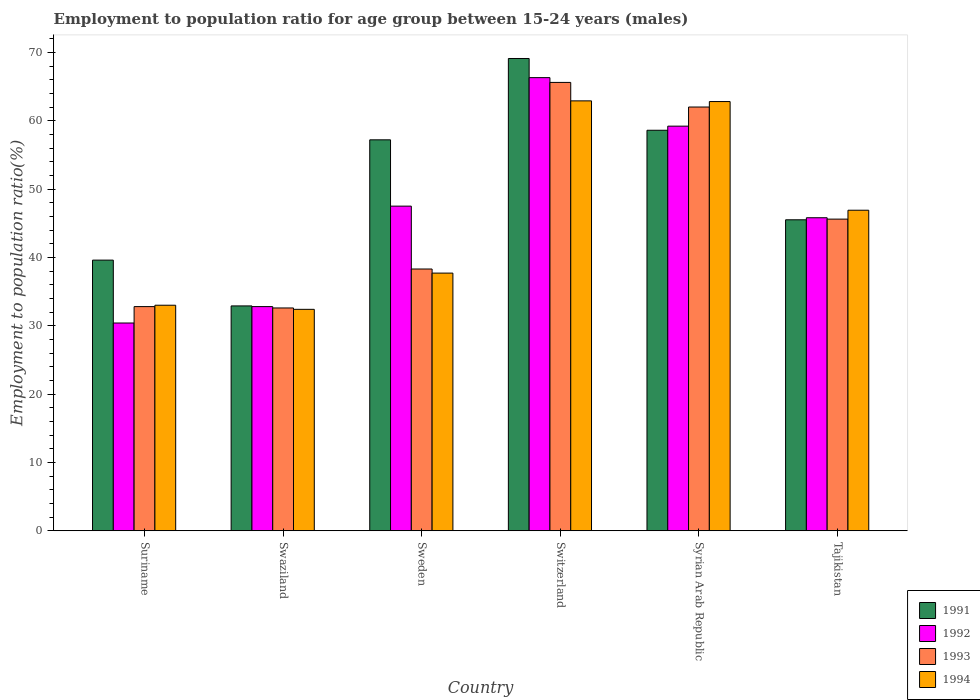How many different coloured bars are there?
Your answer should be very brief. 4. Are the number of bars per tick equal to the number of legend labels?
Give a very brief answer. Yes. How many bars are there on the 4th tick from the left?
Your answer should be compact. 4. What is the label of the 4th group of bars from the left?
Provide a short and direct response. Switzerland. What is the employment to population ratio in 1992 in Syrian Arab Republic?
Your response must be concise. 59.2. Across all countries, what is the maximum employment to population ratio in 1993?
Provide a succinct answer. 65.6. Across all countries, what is the minimum employment to population ratio in 1993?
Provide a short and direct response. 32.6. In which country was the employment to population ratio in 1992 maximum?
Provide a short and direct response. Switzerland. In which country was the employment to population ratio in 1991 minimum?
Offer a terse response. Swaziland. What is the total employment to population ratio in 1991 in the graph?
Provide a short and direct response. 302.9. What is the difference between the employment to population ratio in 1994 in Swaziland and that in Tajikistan?
Keep it short and to the point. -14.5. What is the difference between the employment to population ratio in 1991 in Tajikistan and the employment to population ratio in 1994 in Swaziland?
Your answer should be very brief. 13.1. What is the average employment to population ratio in 1992 per country?
Provide a succinct answer. 47. What is the difference between the employment to population ratio of/in 1993 and employment to population ratio of/in 1994 in Sweden?
Ensure brevity in your answer.  0.6. In how many countries, is the employment to population ratio in 1993 greater than 56 %?
Your answer should be very brief. 2. What is the ratio of the employment to population ratio in 1992 in Suriname to that in Sweden?
Your answer should be compact. 0.64. Is the employment to population ratio in 1994 in Sweden less than that in Tajikistan?
Your answer should be very brief. Yes. Is the difference between the employment to population ratio in 1993 in Suriname and Sweden greater than the difference between the employment to population ratio in 1994 in Suriname and Sweden?
Offer a terse response. No. What is the difference between the highest and the second highest employment to population ratio in 1993?
Provide a short and direct response. 20. What is the difference between the highest and the lowest employment to population ratio in 1992?
Your answer should be very brief. 35.9. Is it the case that in every country, the sum of the employment to population ratio in 1992 and employment to population ratio in 1991 is greater than the sum of employment to population ratio in 1994 and employment to population ratio in 1993?
Your answer should be compact. No. What does the 4th bar from the left in Syrian Arab Republic represents?
Offer a terse response. 1994. What does the 2nd bar from the right in Swaziland represents?
Your response must be concise. 1993. Are the values on the major ticks of Y-axis written in scientific E-notation?
Ensure brevity in your answer.  No. Does the graph contain grids?
Provide a succinct answer. No. What is the title of the graph?
Ensure brevity in your answer.  Employment to population ratio for age group between 15-24 years (males). What is the label or title of the Y-axis?
Offer a terse response. Employment to population ratio(%). What is the Employment to population ratio(%) in 1991 in Suriname?
Keep it short and to the point. 39.6. What is the Employment to population ratio(%) in 1992 in Suriname?
Your response must be concise. 30.4. What is the Employment to population ratio(%) of 1993 in Suriname?
Offer a very short reply. 32.8. What is the Employment to population ratio(%) in 1991 in Swaziland?
Ensure brevity in your answer.  32.9. What is the Employment to population ratio(%) in 1992 in Swaziland?
Give a very brief answer. 32.8. What is the Employment to population ratio(%) of 1993 in Swaziland?
Ensure brevity in your answer.  32.6. What is the Employment to population ratio(%) in 1994 in Swaziland?
Give a very brief answer. 32.4. What is the Employment to population ratio(%) of 1991 in Sweden?
Your answer should be compact. 57.2. What is the Employment to population ratio(%) of 1992 in Sweden?
Provide a short and direct response. 47.5. What is the Employment to population ratio(%) of 1993 in Sweden?
Offer a terse response. 38.3. What is the Employment to population ratio(%) in 1994 in Sweden?
Keep it short and to the point. 37.7. What is the Employment to population ratio(%) of 1991 in Switzerland?
Make the answer very short. 69.1. What is the Employment to population ratio(%) in 1992 in Switzerland?
Ensure brevity in your answer.  66.3. What is the Employment to population ratio(%) of 1993 in Switzerland?
Your response must be concise. 65.6. What is the Employment to population ratio(%) of 1994 in Switzerland?
Your answer should be compact. 62.9. What is the Employment to population ratio(%) of 1991 in Syrian Arab Republic?
Make the answer very short. 58.6. What is the Employment to population ratio(%) in 1992 in Syrian Arab Republic?
Offer a terse response. 59.2. What is the Employment to population ratio(%) of 1993 in Syrian Arab Republic?
Ensure brevity in your answer.  62. What is the Employment to population ratio(%) in 1994 in Syrian Arab Republic?
Your answer should be very brief. 62.8. What is the Employment to population ratio(%) in 1991 in Tajikistan?
Provide a short and direct response. 45.5. What is the Employment to population ratio(%) of 1992 in Tajikistan?
Your answer should be compact. 45.8. What is the Employment to population ratio(%) in 1993 in Tajikistan?
Offer a terse response. 45.6. What is the Employment to population ratio(%) in 1994 in Tajikistan?
Offer a terse response. 46.9. Across all countries, what is the maximum Employment to population ratio(%) of 1991?
Give a very brief answer. 69.1. Across all countries, what is the maximum Employment to population ratio(%) in 1992?
Keep it short and to the point. 66.3. Across all countries, what is the maximum Employment to population ratio(%) in 1993?
Your answer should be compact. 65.6. Across all countries, what is the maximum Employment to population ratio(%) of 1994?
Ensure brevity in your answer.  62.9. Across all countries, what is the minimum Employment to population ratio(%) of 1991?
Give a very brief answer. 32.9. Across all countries, what is the minimum Employment to population ratio(%) of 1992?
Keep it short and to the point. 30.4. Across all countries, what is the minimum Employment to population ratio(%) in 1993?
Offer a very short reply. 32.6. Across all countries, what is the minimum Employment to population ratio(%) of 1994?
Your answer should be compact. 32.4. What is the total Employment to population ratio(%) of 1991 in the graph?
Provide a succinct answer. 302.9. What is the total Employment to population ratio(%) of 1992 in the graph?
Provide a succinct answer. 282. What is the total Employment to population ratio(%) in 1993 in the graph?
Offer a terse response. 276.9. What is the total Employment to population ratio(%) of 1994 in the graph?
Provide a short and direct response. 275.7. What is the difference between the Employment to population ratio(%) of 1992 in Suriname and that in Swaziland?
Make the answer very short. -2.4. What is the difference between the Employment to population ratio(%) of 1994 in Suriname and that in Swaziland?
Ensure brevity in your answer.  0.6. What is the difference between the Employment to population ratio(%) of 1991 in Suriname and that in Sweden?
Your response must be concise. -17.6. What is the difference between the Employment to population ratio(%) in 1992 in Suriname and that in Sweden?
Your answer should be very brief. -17.1. What is the difference between the Employment to population ratio(%) in 1993 in Suriname and that in Sweden?
Ensure brevity in your answer.  -5.5. What is the difference between the Employment to population ratio(%) in 1994 in Suriname and that in Sweden?
Ensure brevity in your answer.  -4.7. What is the difference between the Employment to population ratio(%) of 1991 in Suriname and that in Switzerland?
Give a very brief answer. -29.5. What is the difference between the Employment to population ratio(%) of 1992 in Suriname and that in Switzerland?
Your answer should be very brief. -35.9. What is the difference between the Employment to population ratio(%) of 1993 in Suriname and that in Switzerland?
Provide a succinct answer. -32.8. What is the difference between the Employment to population ratio(%) of 1994 in Suriname and that in Switzerland?
Ensure brevity in your answer.  -29.9. What is the difference between the Employment to population ratio(%) of 1991 in Suriname and that in Syrian Arab Republic?
Offer a very short reply. -19. What is the difference between the Employment to population ratio(%) in 1992 in Suriname and that in Syrian Arab Republic?
Keep it short and to the point. -28.8. What is the difference between the Employment to population ratio(%) of 1993 in Suriname and that in Syrian Arab Republic?
Keep it short and to the point. -29.2. What is the difference between the Employment to population ratio(%) of 1994 in Suriname and that in Syrian Arab Republic?
Offer a very short reply. -29.8. What is the difference between the Employment to population ratio(%) of 1992 in Suriname and that in Tajikistan?
Your answer should be very brief. -15.4. What is the difference between the Employment to population ratio(%) of 1993 in Suriname and that in Tajikistan?
Give a very brief answer. -12.8. What is the difference between the Employment to population ratio(%) in 1994 in Suriname and that in Tajikistan?
Keep it short and to the point. -13.9. What is the difference between the Employment to population ratio(%) in 1991 in Swaziland and that in Sweden?
Your answer should be very brief. -24.3. What is the difference between the Employment to population ratio(%) in 1992 in Swaziland and that in Sweden?
Offer a very short reply. -14.7. What is the difference between the Employment to population ratio(%) in 1993 in Swaziland and that in Sweden?
Your response must be concise. -5.7. What is the difference between the Employment to population ratio(%) of 1994 in Swaziland and that in Sweden?
Your answer should be very brief. -5.3. What is the difference between the Employment to population ratio(%) of 1991 in Swaziland and that in Switzerland?
Give a very brief answer. -36.2. What is the difference between the Employment to population ratio(%) of 1992 in Swaziland and that in Switzerland?
Your response must be concise. -33.5. What is the difference between the Employment to population ratio(%) in 1993 in Swaziland and that in Switzerland?
Give a very brief answer. -33. What is the difference between the Employment to population ratio(%) of 1994 in Swaziland and that in Switzerland?
Provide a short and direct response. -30.5. What is the difference between the Employment to population ratio(%) of 1991 in Swaziland and that in Syrian Arab Republic?
Your answer should be compact. -25.7. What is the difference between the Employment to population ratio(%) in 1992 in Swaziland and that in Syrian Arab Republic?
Your answer should be compact. -26.4. What is the difference between the Employment to population ratio(%) in 1993 in Swaziland and that in Syrian Arab Republic?
Provide a succinct answer. -29.4. What is the difference between the Employment to population ratio(%) in 1994 in Swaziland and that in Syrian Arab Republic?
Your answer should be compact. -30.4. What is the difference between the Employment to population ratio(%) of 1991 in Swaziland and that in Tajikistan?
Your response must be concise. -12.6. What is the difference between the Employment to population ratio(%) of 1992 in Swaziland and that in Tajikistan?
Make the answer very short. -13. What is the difference between the Employment to population ratio(%) of 1993 in Swaziland and that in Tajikistan?
Make the answer very short. -13. What is the difference between the Employment to population ratio(%) of 1994 in Swaziland and that in Tajikistan?
Offer a terse response. -14.5. What is the difference between the Employment to population ratio(%) of 1992 in Sweden and that in Switzerland?
Make the answer very short. -18.8. What is the difference between the Employment to population ratio(%) of 1993 in Sweden and that in Switzerland?
Give a very brief answer. -27.3. What is the difference between the Employment to population ratio(%) in 1994 in Sweden and that in Switzerland?
Keep it short and to the point. -25.2. What is the difference between the Employment to population ratio(%) in 1992 in Sweden and that in Syrian Arab Republic?
Give a very brief answer. -11.7. What is the difference between the Employment to population ratio(%) of 1993 in Sweden and that in Syrian Arab Republic?
Give a very brief answer. -23.7. What is the difference between the Employment to population ratio(%) in 1994 in Sweden and that in Syrian Arab Republic?
Offer a terse response. -25.1. What is the difference between the Employment to population ratio(%) of 1991 in Sweden and that in Tajikistan?
Offer a very short reply. 11.7. What is the difference between the Employment to population ratio(%) in 1993 in Sweden and that in Tajikistan?
Your answer should be very brief. -7.3. What is the difference between the Employment to population ratio(%) of 1994 in Sweden and that in Tajikistan?
Your answer should be compact. -9.2. What is the difference between the Employment to population ratio(%) of 1992 in Switzerland and that in Syrian Arab Republic?
Give a very brief answer. 7.1. What is the difference between the Employment to population ratio(%) in 1993 in Switzerland and that in Syrian Arab Republic?
Your answer should be compact. 3.6. What is the difference between the Employment to population ratio(%) of 1991 in Switzerland and that in Tajikistan?
Your answer should be compact. 23.6. What is the difference between the Employment to population ratio(%) in 1993 in Switzerland and that in Tajikistan?
Offer a very short reply. 20. What is the difference between the Employment to population ratio(%) of 1991 in Syrian Arab Republic and that in Tajikistan?
Offer a terse response. 13.1. What is the difference between the Employment to population ratio(%) in 1992 in Syrian Arab Republic and that in Tajikistan?
Your answer should be very brief. 13.4. What is the difference between the Employment to population ratio(%) of 1994 in Syrian Arab Republic and that in Tajikistan?
Give a very brief answer. 15.9. What is the difference between the Employment to population ratio(%) of 1991 in Suriname and the Employment to population ratio(%) of 1993 in Swaziland?
Offer a terse response. 7. What is the difference between the Employment to population ratio(%) of 1991 in Suriname and the Employment to population ratio(%) of 1992 in Sweden?
Offer a very short reply. -7.9. What is the difference between the Employment to population ratio(%) in 1992 in Suriname and the Employment to population ratio(%) in 1994 in Sweden?
Make the answer very short. -7.3. What is the difference between the Employment to population ratio(%) in 1991 in Suriname and the Employment to population ratio(%) in 1992 in Switzerland?
Offer a very short reply. -26.7. What is the difference between the Employment to population ratio(%) of 1991 in Suriname and the Employment to population ratio(%) of 1993 in Switzerland?
Your response must be concise. -26. What is the difference between the Employment to population ratio(%) in 1991 in Suriname and the Employment to population ratio(%) in 1994 in Switzerland?
Offer a very short reply. -23.3. What is the difference between the Employment to population ratio(%) in 1992 in Suriname and the Employment to population ratio(%) in 1993 in Switzerland?
Provide a succinct answer. -35.2. What is the difference between the Employment to population ratio(%) in 1992 in Suriname and the Employment to population ratio(%) in 1994 in Switzerland?
Ensure brevity in your answer.  -32.5. What is the difference between the Employment to population ratio(%) of 1993 in Suriname and the Employment to population ratio(%) of 1994 in Switzerland?
Ensure brevity in your answer.  -30.1. What is the difference between the Employment to population ratio(%) of 1991 in Suriname and the Employment to population ratio(%) of 1992 in Syrian Arab Republic?
Your response must be concise. -19.6. What is the difference between the Employment to population ratio(%) in 1991 in Suriname and the Employment to population ratio(%) in 1993 in Syrian Arab Republic?
Your response must be concise. -22.4. What is the difference between the Employment to population ratio(%) of 1991 in Suriname and the Employment to population ratio(%) of 1994 in Syrian Arab Republic?
Provide a succinct answer. -23.2. What is the difference between the Employment to population ratio(%) in 1992 in Suriname and the Employment to population ratio(%) in 1993 in Syrian Arab Republic?
Your answer should be very brief. -31.6. What is the difference between the Employment to population ratio(%) of 1992 in Suriname and the Employment to population ratio(%) of 1994 in Syrian Arab Republic?
Ensure brevity in your answer.  -32.4. What is the difference between the Employment to population ratio(%) in 1991 in Suriname and the Employment to population ratio(%) in 1992 in Tajikistan?
Your answer should be compact. -6.2. What is the difference between the Employment to population ratio(%) of 1991 in Suriname and the Employment to population ratio(%) of 1993 in Tajikistan?
Your response must be concise. -6. What is the difference between the Employment to population ratio(%) in 1992 in Suriname and the Employment to population ratio(%) in 1993 in Tajikistan?
Provide a short and direct response. -15.2. What is the difference between the Employment to population ratio(%) of 1992 in Suriname and the Employment to population ratio(%) of 1994 in Tajikistan?
Your answer should be very brief. -16.5. What is the difference between the Employment to population ratio(%) in 1993 in Suriname and the Employment to population ratio(%) in 1994 in Tajikistan?
Ensure brevity in your answer.  -14.1. What is the difference between the Employment to population ratio(%) of 1991 in Swaziland and the Employment to population ratio(%) of 1992 in Sweden?
Keep it short and to the point. -14.6. What is the difference between the Employment to population ratio(%) in 1991 in Swaziland and the Employment to population ratio(%) in 1994 in Sweden?
Ensure brevity in your answer.  -4.8. What is the difference between the Employment to population ratio(%) of 1992 in Swaziland and the Employment to population ratio(%) of 1993 in Sweden?
Keep it short and to the point. -5.5. What is the difference between the Employment to population ratio(%) of 1992 in Swaziland and the Employment to population ratio(%) of 1994 in Sweden?
Your answer should be very brief. -4.9. What is the difference between the Employment to population ratio(%) in 1993 in Swaziland and the Employment to population ratio(%) in 1994 in Sweden?
Make the answer very short. -5.1. What is the difference between the Employment to population ratio(%) in 1991 in Swaziland and the Employment to population ratio(%) in 1992 in Switzerland?
Keep it short and to the point. -33.4. What is the difference between the Employment to population ratio(%) in 1991 in Swaziland and the Employment to population ratio(%) in 1993 in Switzerland?
Keep it short and to the point. -32.7. What is the difference between the Employment to population ratio(%) in 1991 in Swaziland and the Employment to population ratio(%) in 1994 in Switzerland?
Offer a terse response. -30. What is the difference between the Employment to population ratio(%) of 1992 in Swaziland and the Employment to population ratio(%) of 1993 in Switzerland?
Provide a short and direct response. -32.8. What is the difference between the Employment to population ratio(%) of 1992 in Swaziland and the Employment to population ratio(%) of 1994 in Switzerland?
Your answer should be very brief. -30.1. What is the difference between the Employment to population ratio(%) in 1993 in Swaziland and the Employment to population ratio(%) in 1994 in Switzerland?
Your answer should be compact. -30.3. What is the difference between the Employment to population ratio(%) of 1991 in Swaziland and the Employment to population ratio(%) of 1992 in Syrian Arab Republic?
Provide a short and direct response. -26.3. What is the difference between the Employment to population ratio(%) in 1991 in Swaziland and the Employment to population ratio(%) in 1993 in Syrian Arab Republic?
Provide a short and direct response. -29.1. What is the difference between the Employment to population ratio(%) in 1991 in Swaziland and the Employment to population ratio(%) in 1994 in Syrian Arab Republic?
Your answer should be compact. -29.9. What is the difference between the Employment to population ratio(%) in 1992 in Swaziland and the Employment to population ratio(%) in 1993 in Syrian Arab Republic?
Ensure brevity in your answer.  -29.2. What is the difference between the Employment to population ratio(%) of 1993 in Swaziland and the Employment to population ratio(%) of 1994 in Syrian Arab Republic?
Offer a terse response. -30.2. What is the difference between the Employment to population ratio(%) of 1991 in Swaziland and the Employment to population ratio(%) of 1992 in Tajikistan?
Provide a short and direct response. -12.9. What is the difference between the Employment to population ratio(%) in 1992 in Swaziland and the Employment to population ratio(%) in 1994 in Tajikistan?
Give a very brief answer. -14.1. What is the difference between the Employment to population ratio(%) of 1993 in Swaziland and the Employment to population ratio(%) of 1994 in Tajikistan?
Your response must be concise. -14.3. What is the difference between the Employment to population ratio(%) in 1991 in Sweden and the Employment to population ratio(%) in 1992 in Switzerland?
Keep it short and to the point. -9.1. What is the difference between the Employment to population ratio(%) of 1991 in Sweden and the Employment to population ratio(%) of 1994 in Switzerland?
Ensure brevity in your answer.  -5.7. What is the difference between the Employment to population ratio(%) in 1992 in Sweden and the Employment to population ratio(%) in 1993 in Switzerland?
Your answer should be compact. -18.1. What is the difference between the Employment to population ratio(%) of 1992 in Sweden and the Employment to population ratio(%) of 1994 in Switzerland?
Keep it short and to the point. -15.4. What is the difference between the Employment to population ratio(%) in 1993 in Sweden and the Employment to population ratio(%) in 1994 in Switzerland?
Ensure brevity in your answer.  -24.6. What is the difference between the Employment to population ratio(%) of 1991 in Sweden and the Employment to population ratio(%) of 1993 in Syrian Arab Republic?
Your answer should be very brief. -4.8. What is the difference between the Employment to population ratio(%) in 1992 in Sweden and the Employment to population ratio(%) in 1994 in Syrian Arab Republic?
Provide a short and direct response. -15.3. What is the difference between the Employment to population ratio(%) in 1993 in Sweden and the Employment to population ratio(%) in 1994 in Syrian Arab Republic?
Ensure brevity in your answer.  -24.5. What is the difference between the Employment to population ratio(%) of 1991 in Sweden and the Employment to population ratio(%) of 1992 in Tajikistan?
Provide a succinct answer. 11.4. What is the difference between the Employment to population ratio(%) of 1991 in Sweden and the Employment to population ratio(%) of 1994 in Tajikistan?
Your answer should be very brief. 10.3. What is the difference between the Employment to population ratio(%) in 1992 in Sweden and the Employment to population ratio(%) in 1993 in Tajikistan?
Ensure brevity in your answer.  1.9. What is the difference between the Employment to population ratio(%) in 1993 in Sweden and the Employment to population ratio(%) in 1994 in Tajikistan?
Make the answer very short. -8.6. What is the difference between the Employment to population ratio(%) of 1991 in Switzerland and the Employment to population ratio(%) of 1992 in Syrian Arab Republic?
Ensure brevity in your answer.  9.9. What is the difference between the Employment to population ratio(%) of 1991 in Switzerland and the Employment to population ratio(%) of 1993 in Syrian Arab Republic?
Keep it short and to the point. 7.1. What is the difference between the Employment to population ratio(%) in 1991 in Switzerland and the Employment to population ratio(%) in 1992 in Tajikistan?
Ensure brevity in your answer.  23.3. What is the difference between the Employment to population ratio(%) of 1991 in Switzerland and the Employment to population ratio(%) of 1993 in Tajikistan?
Keep it short and to the point. 23.5. What is the difference between the Employment to population ratio(%) in 1991 in Switzerland and the Employment to population ratio(%) in 1994 in Tajikistan?
Offer a very short reply. 22.2. What is the difference between the Employment to population ratio(%) of 1992 in Switzerland and the Employment to population ratio(%) of 1993 in Tajikistan?
Provide a short and direct response. 20.7. What is the difference between the Employment to population ratio(%) of 1992 in Switzerland and the Employment to population ratio(%) of 1994 in Tajikistan?
Ensure brevity in your answer.  19.4. What is the difference between the Employment to population ratio(%) in 1993 in Switzerland and the Employment to population ratio(%) in 1994 in Tajikistan?
Ensure brevity in your answer.  18.7. What is the difference between the Employment to population ratio(%) in 1991 in Syrian Arab Republic and the Employment to population ratio(%) in 1992 in Tajikistan?
Offer a terse response. 12.8. What is the difference between the Employment to population ratio(%) in 1991 in Syrian Arab Republic and the Employment to population ratio(%) in 1993 in Tajikistan?
Your response must be concise. 13. What is the difference between the Employment to population ratio(%) of 1991 in Syrian Arab Republic and the Employment to population ratio(%) of 1994 in Tajikistan?
Make the answer very short. 11.7. What is the difference between the Employment to population ratio(%) of 1992 in Syrian Arab Republic and the Employment to population ratio(%) of 1993 in Tajikistan?
Provide a short and direct response. 13.6. What is the difference between the Employment to population ratio(%) in 1992 in Syrian Arab Republic and the Employment to population ratio(%) in 1994 in Tajikistan?
Offer a very short reply. 12.3. What is the difference between the Employment to population ratio(%) of 1993 in Syrian Arab Republic and the Employment to population ratio(%) of 1994 in Tajikistan?
Your answer should be compact. 15.1. What is the average Employment to population ratio(%) of 1991 per country?
Your answer should be very brief. 50.48. What is the average Employment to population ratio(%) in 1992 per country?
Provide a short and direct response. 47. What is the average Employment to population ratio(%) of 1993 per country?
Offer a very short reply. 46.15. What is the average Employment to population ratio(%) in 1994 per country?
Provide a succinct answer. 45.95. What is the difference between the Employment to population ratio(%) in 1991 and Employment to population ratio(%) in 1992 in Suriname?
Your answer should be very brief. 9.2. What is the difference between the Employment to population ratio(%) of 1991 and Employment to population ratio(%) of 1993 in Suriname?
Offer a very short reply. 6.8. What is the difference between the Employment to population ratio(%) in 1993 and Employment to population ratio(%) in 1994 in Suriname?
Ensure brevity in your answer.  -0.2. What is the difference between the Employment to population ratio(%) in 1991 and Employment to population ratio(%) in 1992 in Swaziland?
Make the answer very short. 0.1. What is the difference between the Employment to population ratio(%) of 1991 and Employment to population ratio(%) of 1994 in Swaziland?
Provide a short and direct response. 0.5. What is the difference between the Employment to population ratio(%) in 1992 and Employment to population ratio(%) in 1994 in Swaziland?
Provide a succinct answer. 0.4. What is the difference between the Employment to population ratio(%) in 1991 and Employment to population ratio(%) in 1994 in Sweden?
Offer a very short reply. 19.5. What is the difference between the Employment to population ratio(%) of 1992 and Employment to population ratio(%) of 1994 in Sweden?
Your answer should be very brief. 9.8. What is the difference between the Employment to population ratio(%) in 1991 and Employment to population ratio(%) in 1992 in Switzerland?
Provide a short and direct response. 2.8. What is the difference between the Employment to population ratio(%) of 1991 and Employment to population ratio(%) of 1994 in Switzerland?
Your answer should be compact. 6.2. What is the difference between the Employment to population ratio(%) of 1992 and Employment to population ratio(%) of 1993 in Switzerland?
Give a very brief answer. 0.7. What is the difference between the Employment to population ratio(%) in 1991 and Employment to population ratio(%) in 1992 in Syrian Arab Republic?
Provide a short and direct response. -0.6. What is the difference between the Employment to population ratio(%) in 1991 and Employment to population ratio(%) in 1994 in Syrian Arab Republic?
Your answer should be compact. -4.2. What is the difference between the Employment to population ratio(%) of 1992 and Employment to population ratio(%) of 1993 in Syrian Arab Republic?
Provide a short and direct response. -2.8. What is the difference between the Employment to population ratio(%) of 1991 and Employment to population ratio(%) of 1993 in Tajikistan?
Make the answer very short. -0.1. What is the difference between the Employment to population ratio(%) of 1992 and Employment to population ratio(%) of 1993 in Tajikistan?
Provide a short and direct response. 0.2. What is the difference between the Employment to population ratio(%) of 1992 and Employment to population ratio(%) of 1994 in Tajikistan?
Your response must be concise. -1.1. What is the difference between the Employment to population ratio(%) in 1993 and Employment to population ratio(%) in 1994 in Tajikistan?
Provide a short and direct response. -1.3. What is the ratio of the Employment to population ratio(%) in 1991 in Suriname to that in Swaziland?
Ensure brevity in your answer.  1.2. What is the ratio of the Employment to population ratio(%) of 1992 in Suriname to that in Swaziland?
Provide a succinct answer. 0.93. What is the ratio of the Employment to population ratio(%) in 1993 in Suriname to that in Swaziland?
Your answer should be compact. 1.01. What is the ratio of the Employment to population ratio(%) of 1994 in Suriname to that in Swaziland?
Your answer should be compact. 1.02. What is the ratio of the Employment to population ratio(%) of 1991 in Suriname to that in Sweden?
Provide a succinct answer. 0.69. What is the ratio of the Employment to population ratio(%) in 1992 in Suriname to that in Sweden?
Your response must be concise. 0.64. What is the ratio of the Employment to population ratio(%) of 1993 in Suriname to that in Sweden?
Provide a succinct answer. 0.86. What is the ratio of the Employment to population ratio(%) in 1994 in Suriname to that in Sweden?
Provide a short and direct response. 0.88. What is the ratio of the Employment to population ratio(%) in 1991 in Suriname to that in Switzerland?
Give a very brief answer. 0.57. What is the ratio of the Employment to population ratio(%) in 1992 in Suriname to that in Switzerland?
Your answer should be very brief. 0.46. What is the ratio of the Employment to population ratio(%) in 1994 in Suriname to that in Switzerland?
Ensure brevity in your answer.  0.52. What is the ratio of the Employment to population ratio(%) in 1991 in Suriname to that in Syrian Arab Republic?
Provide a short and direct response. 0.68. What is the ratio of the Employment to population ratio(%) in 1992 in Suriname to that in Syrian Arab Republic?
Your answer should be compact. 0.51. What is the ratio of the Employment to population ratio(%) of 1993 in Suriname to that in Syrian Arab Republic?
Your answer should be very brief. 0.53. What is the ratio of the Employment to population ratio(%) in 1994 in Suriname to that in Syrian Arab Republic?
Give a very brief answer. 0.53. What is the ratio of the Employment to population ratio(%) of 1991 in Suriname to that in Tajikistan?
Make the answer very short. 0.87. What is the ratio of the Employment to population ratio(%) in 1992 in Suriname to that in Tajikistan?
Ensure brevity in your answer.  0.66. What is the ratio of the Employment to population ratio(%) of 1993 in Suriname to that in Tajikistan?
Provide a succinct answer. 0.72. What is the ratio of the Employment to population ratio(%) in 1994 in Suriname to that in Tajikistan?
Keep it short and to the point. 0.7. What is the ratio of the Employment to population ratio(%) of 1991 in Swaziland to that in Sweden?
Keep it short and to the point. 0.58. What is the ratio of the Employment to population ratio(%) of 1992 in Swaziland to that in Sweden?
Keep it short and to the point. 0.69. What is the ratio of the Employment to population ratio(%) in 1993 in Swaziland to that in Sweden?
Make the answer very short. 0.85. What is the ratio of the Employment to population ratio(%) in 1994 in Swaziland to that in Sweden?
Make the answer very short. 0.86. What is the ratio of the Employment to population ratio(%) in 1991 in Swaziland to that in Switzerland?
Keep it short and to the point. 0.48. What is the ratio of the Employment to population ratio(%) of 1992 in Swaziland to that in Switzerland?
Make the answer very short. 0.49. What is the ratio of the Employment to population ratio(%) of 1993 in Swaziland to that in Switzerland?
Offer a terse response. 0.5. What is the ratio of the Employment to population ratio(%) in 1994 in Swaziland to that in Switzerland?
Keep it short and to the point. 0.52. What is the ratio of the Employment to population ratio(%) in 1991 in Swaziland to that in Syrian Arab Republic?
Your answer should be very brief. 0.56. What is the ratio of the Employment to population ratio(%) in 1992 in Swaziland to that in Syrian Arab Republic?
Offer a terse response. 0.55. What is the ratio of the Employment to population ratio(%) in 1993 in Swaziland to that in Syrian Arab Republic?
Keep it short and to the point. 0.53. What is the ratio of the Employment to population ratio(%) of 1994 in Swaziland to that in Syrian Arab Republic?
Give a very brief answer. 0.52. What is the ratio of the Employment to population ratio(%) of 1991 in Swaziland to that in Tajikistan?
Your answer should be compact. 0.72. What is the ratio of the Employment to population ratio(%) of 1992 in Swaziland to that in Tajikistan?
Provide a succinct answer. 0.72. What is the ratio of the Employment to population ratio(%) in 1993 in Swaziland to that in Tajikistan?
Offer a very short reply. 0.71. What is the ratio of the Employment to population ratio(%) of 1994 in Swaziland to that in Tajikistan?
Keep it short and to the point. 0.69. What is the ratio of the Employment to population ratio(%) of 1991 in Sweden to that in Switzerland?
Your answer should be compact. 0.83. What is the ratio of the Employment to population ratio(%) in 1992 in Sweden to that in Switzerland?
Offer a very short reply. 0.72. What is the ratio of the Employment to population ratio(%) in 1993 in Sweden to that in Switzerland?
Give a very brief answer. 0.58. What is the ratio of the Employment to population ratio(%) of 1994 in Sweden to that in Switzerland?
Provide a succinct answer. 0.6. What is the ratio of the Employment to population ratio(%) of 1991 in Sweden to that in Syrian Arab Republic?
Your response must be concise. 0.98. What is the ratio of the Employment to population ratio(%) of 1992 in Sweden to that in Syrian Arab Republic?
Keep it short and to the point. 0.8. What is the ratio of the Employment to population ratio(%) of 1993 in Sweden to that in Syrian Arab Republic?
Offer a terse response. 0.62. What is the ratio of the Employment to population ratio(%) of 1994 in Sweden to that in Syrian Arab Republic?
Make the answer very short. 0.6. What is the ratio of the Employment to population ratio(%) of 1991 in Sweden to that in Tajikistan?
Provide a short and direct response. 1.26. What is the ratio of the Employment to population ratio(%) of 1992 in Sweden to that in Tajikistan?
Your answer should be compact. 1.04. What is the ratio of the Employment to population ratio(%) of 1993 in Sweden to that in Tajikistan?
Your response must be concise. 0.84. What is the ratio of the Employment to population ratio(%) in 1994 in Sweden to that in Tajikistan?
Your answer should be very brief. 0.8. What is the ratio of the Employment to population ratio(%) of 1991 in Switzerland to that in Syrian Arab Republic?
Make the answer very short. 1.18. What is the ratio of the Employment to population ratio(%) in 1992 in Switzerland to that in Syrian Arab Republic?
Your answer should be compact. 1.12. What is the ratio of the Employment to population ratio(%) of 1993 in Switzerland to that in Syrian Arab Republic?
Provide a short and direct response. 1.06. What is the ratio of the Employment to population ratio(%) in 1991 in Switzerland to that in Tajikistan?
Provide a short and direct response. 1.52. What is the ratio of the Employment to population ratio(%) in 1992 in Switzerland to that in Tajikistan?
Your answer should be compact. 1.45. What is the ratio of the Employment to population ratio(%) of 1993 in Switzerland to that in Tajikistan?
Provide a succinct answer. 1.44. What is the ratio of the Employment to population ratio(%) of 1994 in Switzerland to that in Tajikistan?
Keep it short and to the point. 1.34. What is the ratio of the Employment to population ratio(%) of 1991 in Syrian Arab Republic to that in Tajikistan?
Your answer should be very brief. 1.29. What is the ratio of the Employment to population ratio(%) of 1992 in Syrian Arab Republic to that in Tajikistan?
Ensure brevity in your answer.  1.29. What is the ratio of the Employment to population ratio(%) in 1993 in Syrian Arab Republic to that in Tajikistan?
Make the answer very short. 1.36. What is the ratio of the Employment to population ratio(%) in 1994 in Syrian Arab Republic to that in Tajikistan?
Offer a very short reply. 1.34. What is the difference between the highest and the second highest Employment to population ratio(%) in 1991?
Your answer should be compact. 10.5. What is the difference between the highest and the second highest Employment to population ratio(%) of 1993?
Your response must be concise. 3.6. What is the difference between the highest and the lowest Employment to population ratio(%) of 1991?
Keep it short and to the point. 36.2. What is the difference between the highest and the lowest Employment to population ratio(%) of 1992?
Make the answer very short. 35.9. What is the difference between the highest and the lowest Employment to population ratio(%) in 1993?
Provide a short and direct response. 33. What is the difference between the highest and the lowest Employment to population ratio(%) in 1994?
Give a very brief answer. 30.5. 